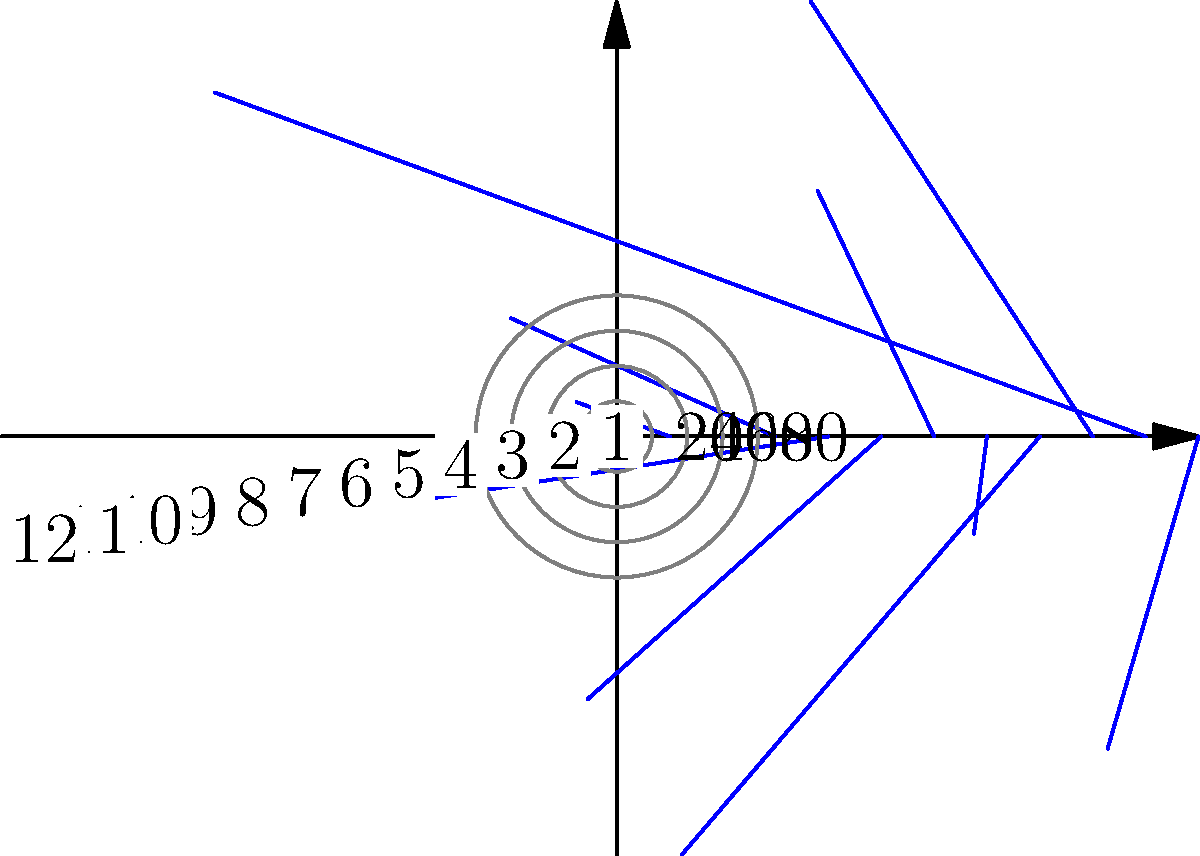The polar rose diagram above shows the number of visitors to Yellowstone National Park throughout the year. Each petal represents a month, with the length indicating the number of visitors (in thousands). Which month has the highest number of visitors, and what strategy could you implement in your ecotourism business to capitalize on this peak season while promoting sustainable tourism? To answer this question, we need to follow these steps:

1. Understand the diagram:
   - Each petal represents a month (1-12, starting from January)
   - The length of each petal indicates the number of visitors in thousands

2. Identify the longest petal:
   - The longest petal corresponds to the 6th month (June)
   - This petal extends to the 80 mark on the radial axis

3. Interpret the data:
   - June has the highest number of visitors at 80,000

4. Consider ecotourism strategies:
   - Recognize that peak season (June) puts the most stress on the park's ecosystem
   - Develop strategies to balance economic benefits with environmental conservation
   - Possible ideas include:
     a. Offering educational programs about the park's ecosystem and conservation efforts
     b. Implementing a visitor quota system to prevent overcrowding
     c. Promoting off-peak season visits with special eco-friendly activities
     d. Partnering with local communities to provide authentic, sustainable experiences
     e. Introducing a "green fee" during peak season to fund conservation efforts

5. Formulate a concise answer that addresses both parts of the question
Answer: June (80,000 visitors). Implement visitor quotas and eco-education programs during peak season; promote off-peak sustainable activities. 